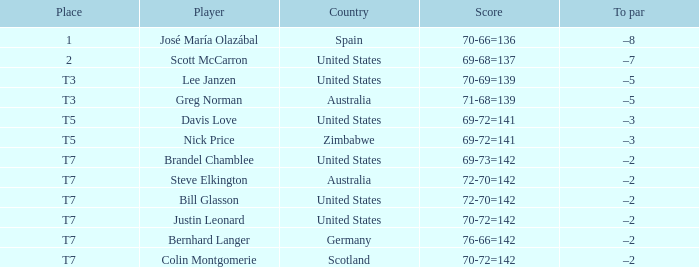Which score has a below par of -3, and a nation of united states? 69-72=141. Would you be able to parse every entry in this table? {'header': ['Place', 'Player', 'Country', 'Score', 'To par'], 'rows': [['1', 'José María Olazábal', 'Spain', '70-66=136', '–8'], ['2', 'Scott McCarron', 'United States', '69-68=137', '–7'], ['T3', 'Lee Janzen', 'United States', '70-69=139', '–5'], ['T3', 'Greg Norman', 'Australia', '71-68=139', '–5'], ['T5', 'Davis Love', 'United States', '69-72=141', '–3'], ['T5', 'Nick Price', 'Zimbabwe', '69-72=141', '–3'], ['T7', 'Brandel Chamblee', 'United States', '69-73=142', '–2'], ['T7', 'Steve Elkington', 'Australia', '72-70=142', '–2'], ['T7', 'Bill Glasson', 'United States', '72-70=142', '–2'], ['T7', 'Justin Leonard', 'United States', '70-72=142', '–2'], ['T7', 'Bernhard Langer', 'Germany', '76-66=142', '–2'], ['T7', 'Colin Montgomerie', 'Scotland', '70-72=142', '–2']]} 